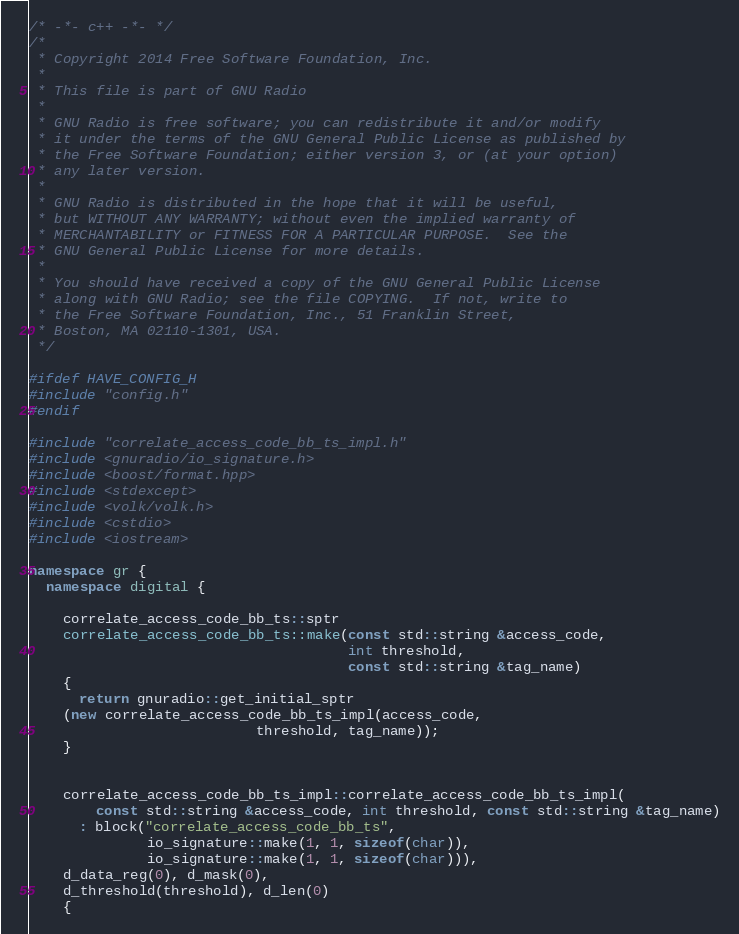<code> <loc_0><loc_0><loc_500><loc_500><_C++_>/* -*- c++ -*- */
/*
 * Copyright 2014 Free Software Foundation, Inc.
 *
 * This file is part of GNU Radio
 *
 * GNU Radio is free software; you can redistribute it and/or modify
 * it under the terms of the GNU General Public License as published by
 * the Free Software Foundation; either version 3, or (at your option)
 * any later version.
 *
 * GNU Radio is distributed in the hope that it will be useful,
 * but WITHOUT ANY WARRANTY; without even the implied warranty of
 * MERCHANTABILITY or FITNESS FOR A PARTICULAR PURPOSE.  See the
 * GNU General Public License for more details.
 *
 * You should have received a copy of the GNU General Public License
 * along with GNU Radio; see the file COPYING.  If not, write to
 * the Free Software Foundation, Inc., 51 Franklin Street,
 * Boston, MA 02110-1301, USA.
 */

#ifdef HAVE_CONFIG_H
#include "config.h"
#endif

#include "correlate_access_code_bb_ts_impl.h"
#include <gnuradio/io_signature.h>
#include <boost/format.hpp>
#include <stdexcept>
#include <volk/volk.h>
#include <cstdio>
#include <iostream>

namespace gr {
  namespace digital {

    correlate_access_code_bb_ts::sptr
    correlate_access_code_bb_ts::make(const std::string &access_code,
                                      int threshold,
                                      const std::string &tag_name)
    {
      return gnuradio::get_initial_sptr
	(new correlate_access_code_bb_ts_impl(access_code,
					       threshold, tag_name));
    }


    correlate_access_code_bb_ts_impl::correlate_access_code_bb_ts_impl(
        const std::string &access_code, int threshold, const std::string &tag_name)
      : block("correlate_access_code_bb_ts",
              io_signature::make(1, 1, sizeof(char)),
              io_signature::make(1, 1, sizeof(char))),
	d_data_reg(0), d_mask(0),
	d_threshold(threshold), d_len(0)
    {</code> 